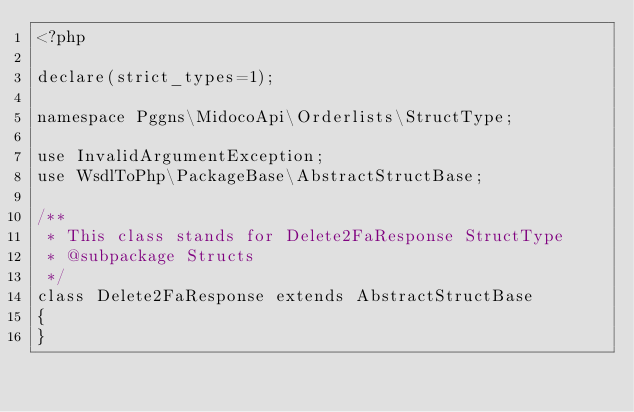Convert code to text. <code><loc_0><loc_0><loc_500><loc_500><_PHP_><?php

declare(strict_types=1);

namespace Pggns\MidocoApi\Orderlists\StructType;

use InvalidArgumentException;
use WsdlToPhp\PackageBase\AbstractStructBase;

/**
 * This class stands for Delete2FaResponse StructType
 * @subpackage Structs
 */
class Delete2FaResponse extends AbstractStructBase
{
}
</code> 